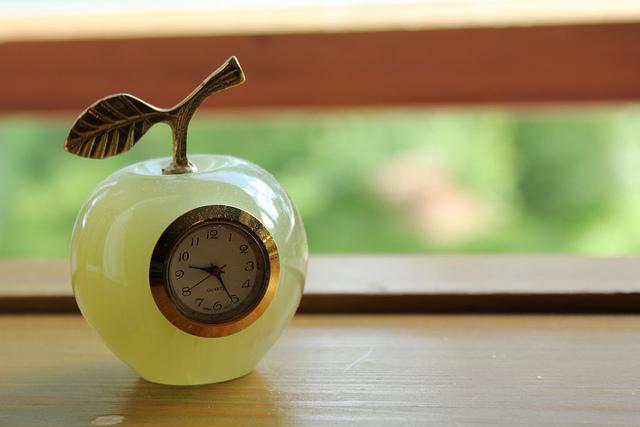What fruit is the clock?
Keep it brief. Apple. What is  mainly featured?
Give a very brief answer. Clock. What color is the glass apple?
Give a very brief answer. Green. 